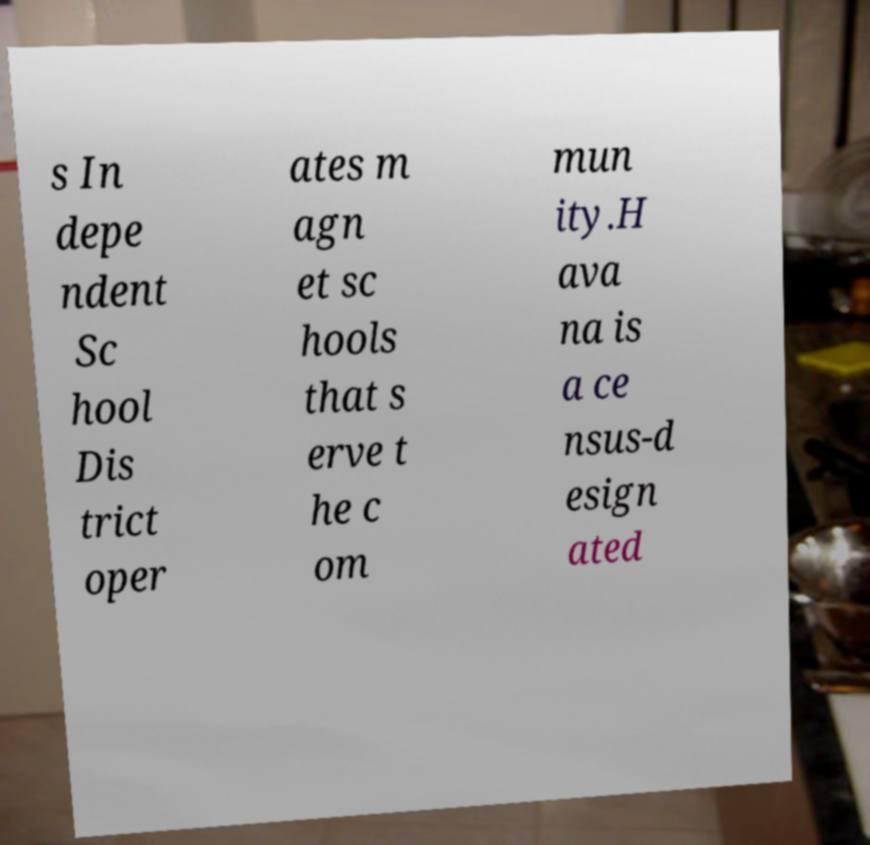Can you read and provide the text displayed in the image?This photo seems to have some interesting text. Can you extract and type it out for me? s In depe ndent Sc hool Dis trict oper ates m agn et sc hools that s erve t he c om mun ity.H ava na is a ce nsus-d esign ated 